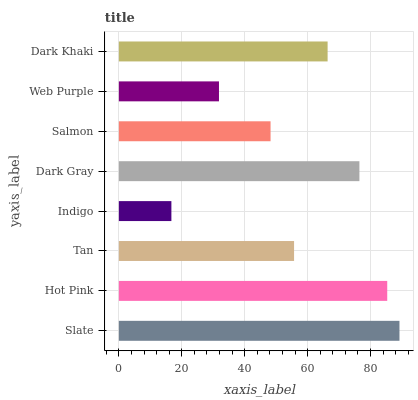Is Indigo the minimum?
Answer yes or no. Yes. Is Slate the maximum?
Answer yes or no. Yes. Is Hot Pink the minimum?
Answer yes or no. No. Is Hot Pink the maximum?
Answer yes or no. No. Is Slate greater than Hot Pink?
Answer yes or no. Yes. Is Hot Pink less than Slate?
Answer yes or no. Yes. Is Hot Pink greater than Slate?
Answer yes or no. No. Is Slate less than Hot Pink?
Answer yes or no. No. Is Dark Khaki the high median?
Answer yes or no. Yes. Is Tan the low median?
Answer yes or no. Yes. Is Slate the high median?
Answer yes or no. No. Is Salmon the low median?
Answer yes or no. No. 